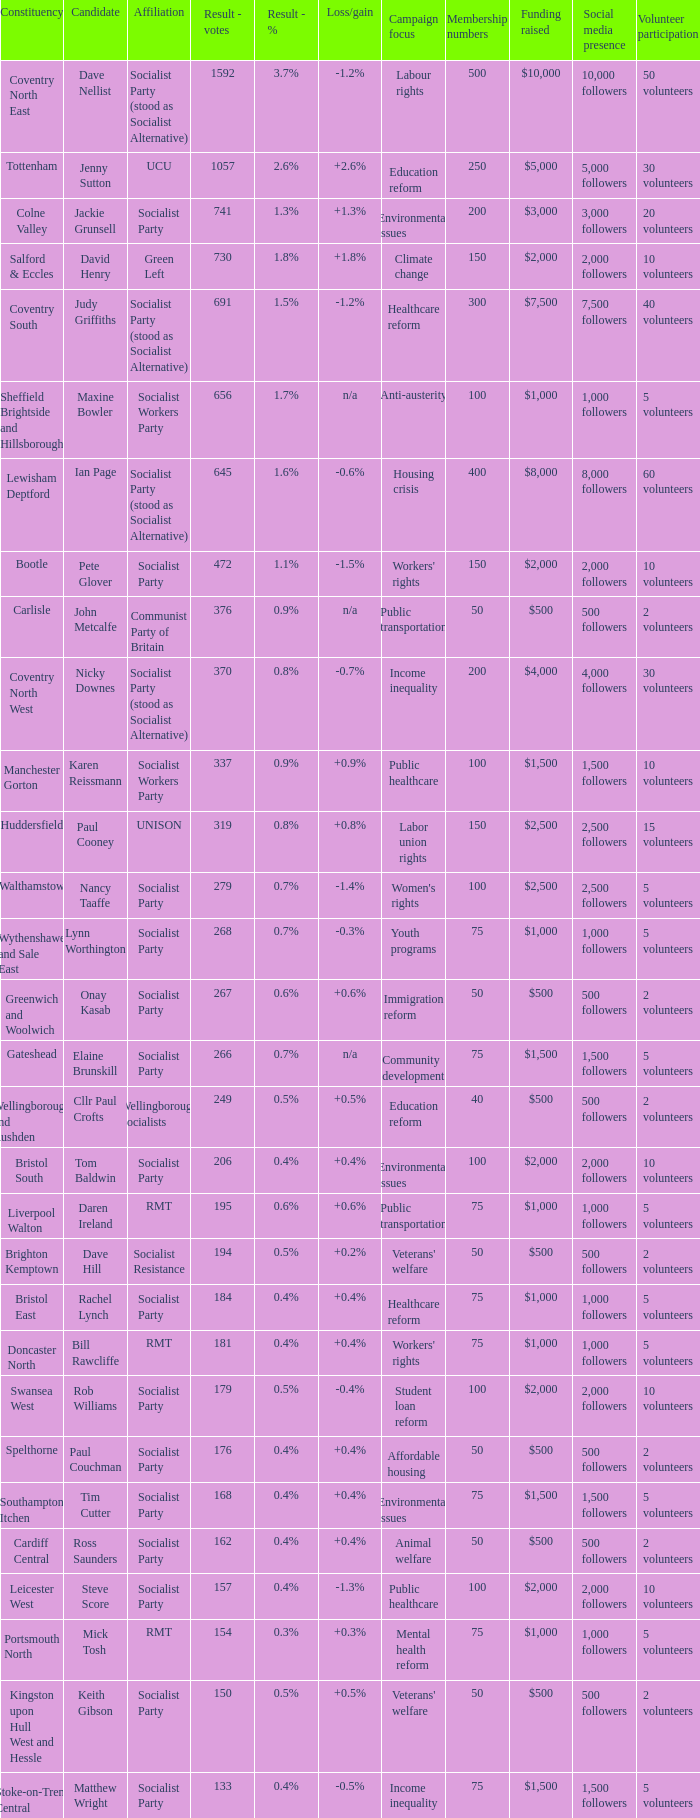What are all the relationships for the tottenham constituency? UCU. 